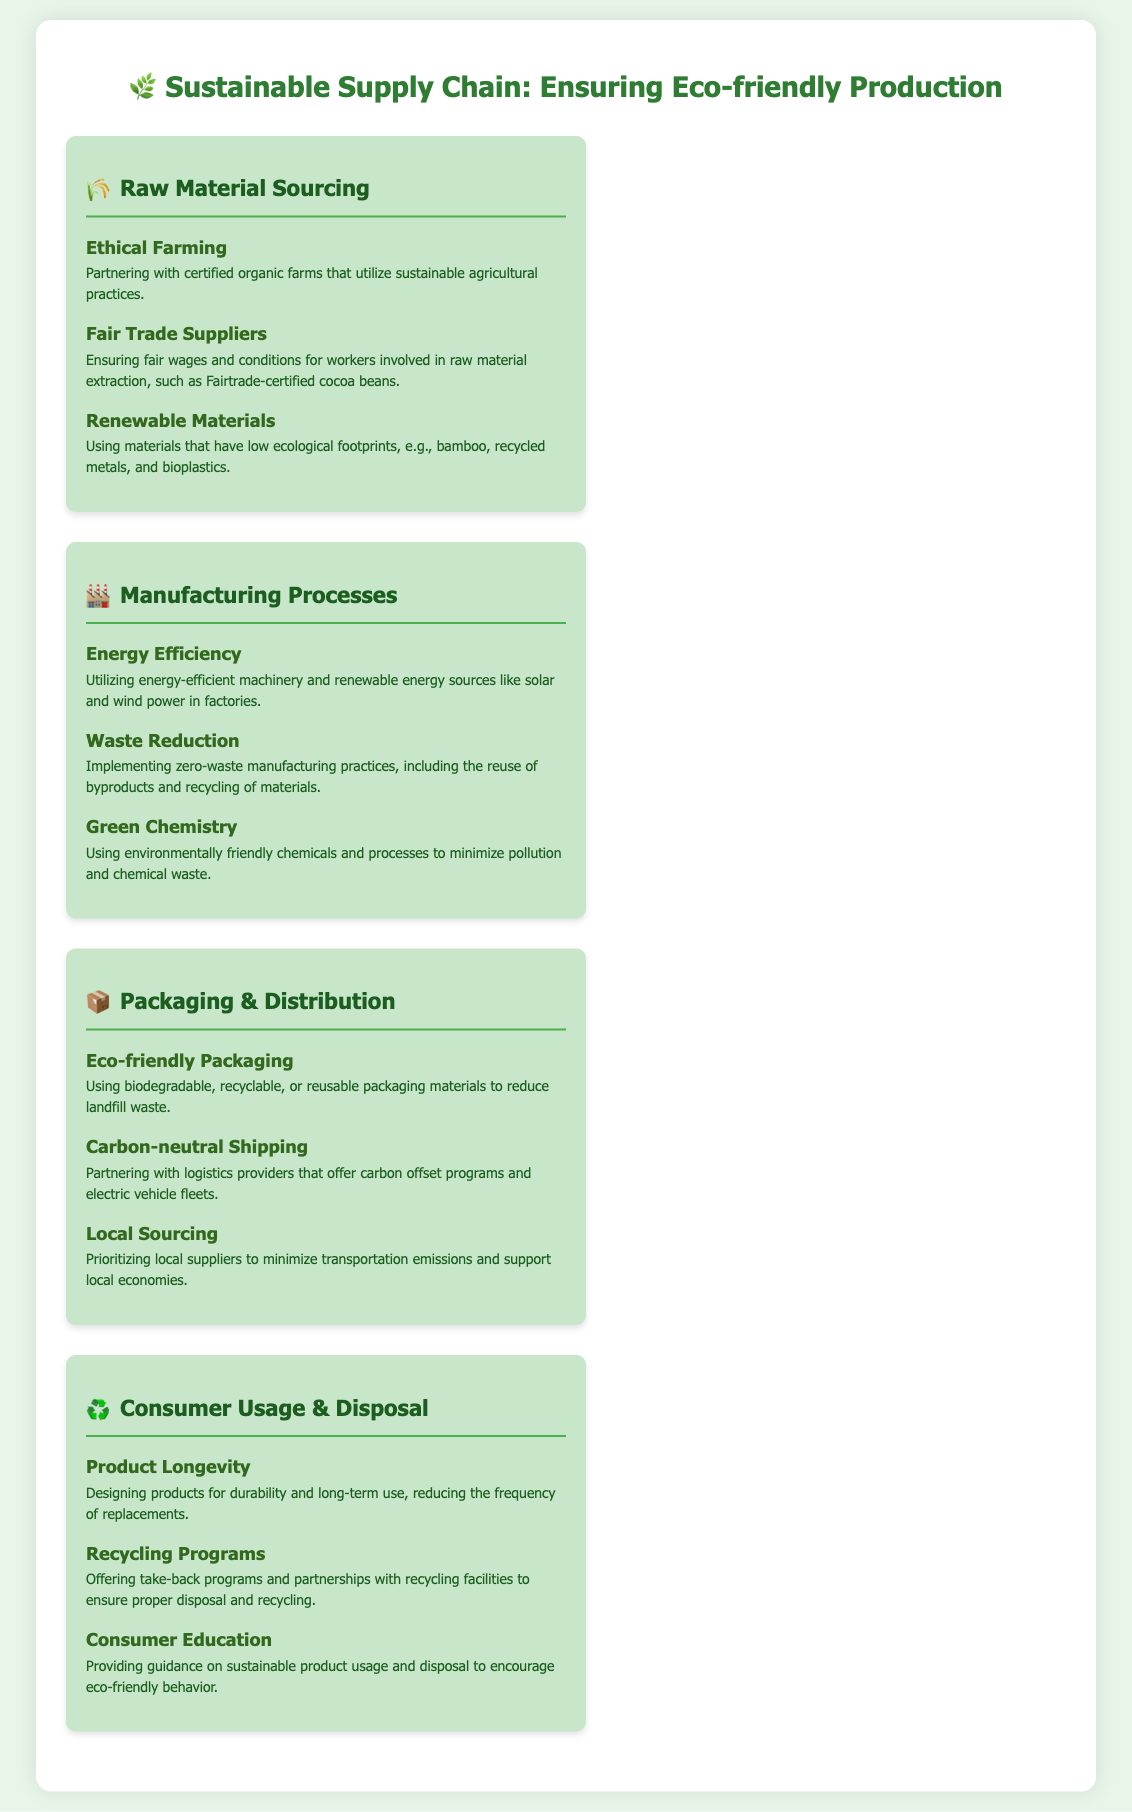What is the first stage of the sustainable supply chain? The first stage of the sustainable supply chain highlighted in the infographic is Raw Material Sourcing.
Answer: Raw Material Sourcing What type of farming is used for raw material sourcing? The infographic mentions partnering with certified organic farms that utilize sustainable agricultural practices.
Answer: Ethical Farming What is one method used in manufacturing to minimize pollution? The document states that Green Chemistry is used to minimize pollution and chemical waste in manufacturing.
Answer: Green Chemistry What kind of packaging materials are promoted in the infographic? The infographic emphasizes using biodegradable, recyclable, or reusable packaging materials.
Answer: Eco-friendly Packaging How do companies aim to reduce transportation emissions? The infographic suggests that companies prioritize local suppliers to minimize transportation emissions and support local economies.
Answer: Local Sourcing What is a requirement for Fair Trade Suppliers mentioned in the document? The infographic ensures that Fair Trade Suppliers provide fair wages and conditions for workers.
Answer: Fair wages Which process aims to reduce waste in manufacturing? The infographic details Waste Reduction as implementing zero-waste manufacturing practices.
Answer: Waste Reduction What is the goal of consumer education according to the infographic? The document states that the goal is to provide guidance on sustainable product usage and disposal.
Answer: Sustainable product usage What type of shipping practices are mentioned in the packaging and distribution section? The infographic mentions partnering with logistics providers that offer carbon offset programs and electric vehicle fleets for shipping.
Answer: Carbon-neutral Shipping 